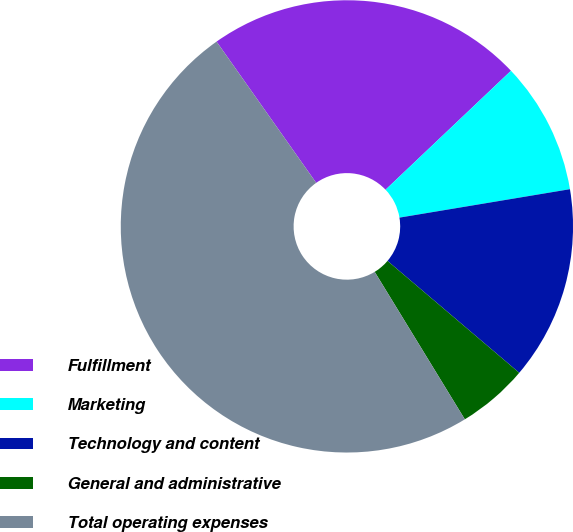Convert chart to OTSL. <chart><loc_0><loc_0><loc_500><loc_500><pie_chart><fcel>Fulfillment<fcel>Marketing<fcel>Technology and content<fcel>General and administrative<fcel>Total operating expenses<nl><fcel>22.7%<fcel>9.45%<fcel>13.84%<fcel>5.06%<fcel>48.96%<nl></chart> 